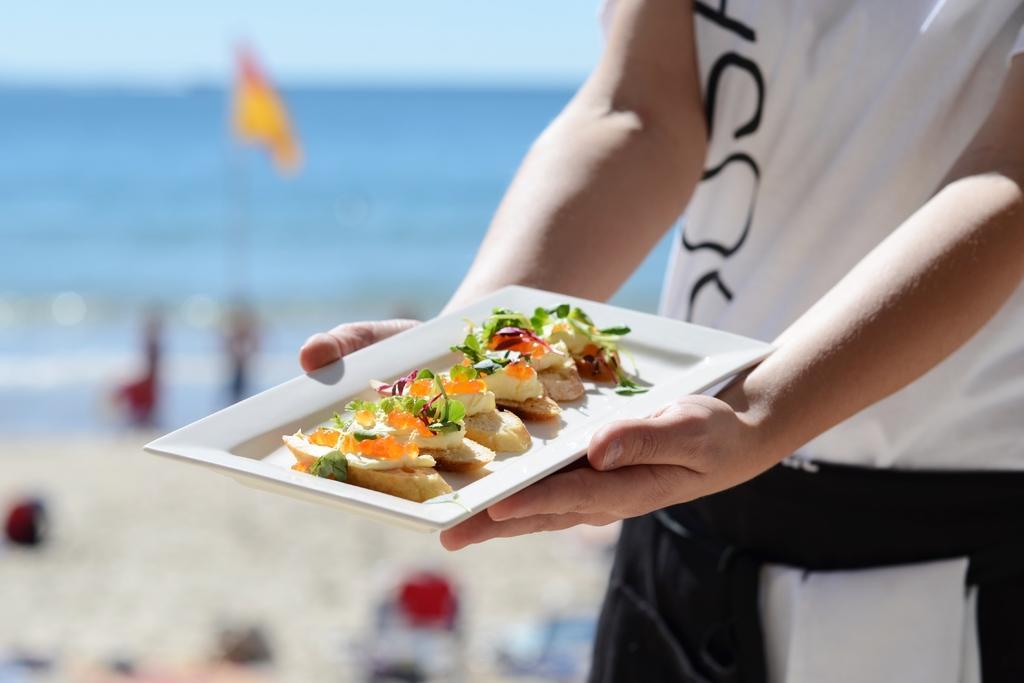Please provide a concise description of this image. On the right side of the image we can see a man standing and holding a plate in his hand. We can see some food on the plate. In the background there is a sea. 